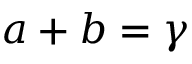Convert formula to latex. <formula><loc_0><loc_0><loc_500><loc_500>a + b = \gamma</formula> 